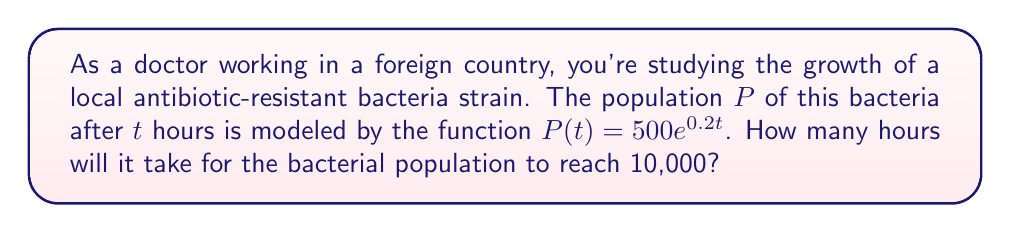What is the answer to this math problem? Let's approach this step-by-step:

1) We're given the exponential function $P(t) = 500e^{0.2t}$, where:
   $P(t)$ is the population after $t$ hours
   500 is the initial population
   0.2 is the growth rate

2) We want to find $t$ when $P(t) = 10,000$. So, let's set up the equation:

   $10,000 = 500e^{0.2t}$

3) Divide both sides by 500:

   $20 = e^{0.2t}$

4) Take the natural logarithm of both sides:

   $\ln(20) = \ln(e^{0.2t})$

5) Simplify the right side using the logarithm property $\ln(e^x) = x$:

   $\ln(20) = 0.2t$

6) Solve for $t$ by dividing both sides by 0.2:

   $t = \frac{\ln(20)}{0.2}$

7) Calculate the result:

   $t = \frac{\ln(20)}{0.2} \approx 14.98$ hours

8) Since we're dealing with whole hours, we round up to the next hour.
Answer: 15 hours 